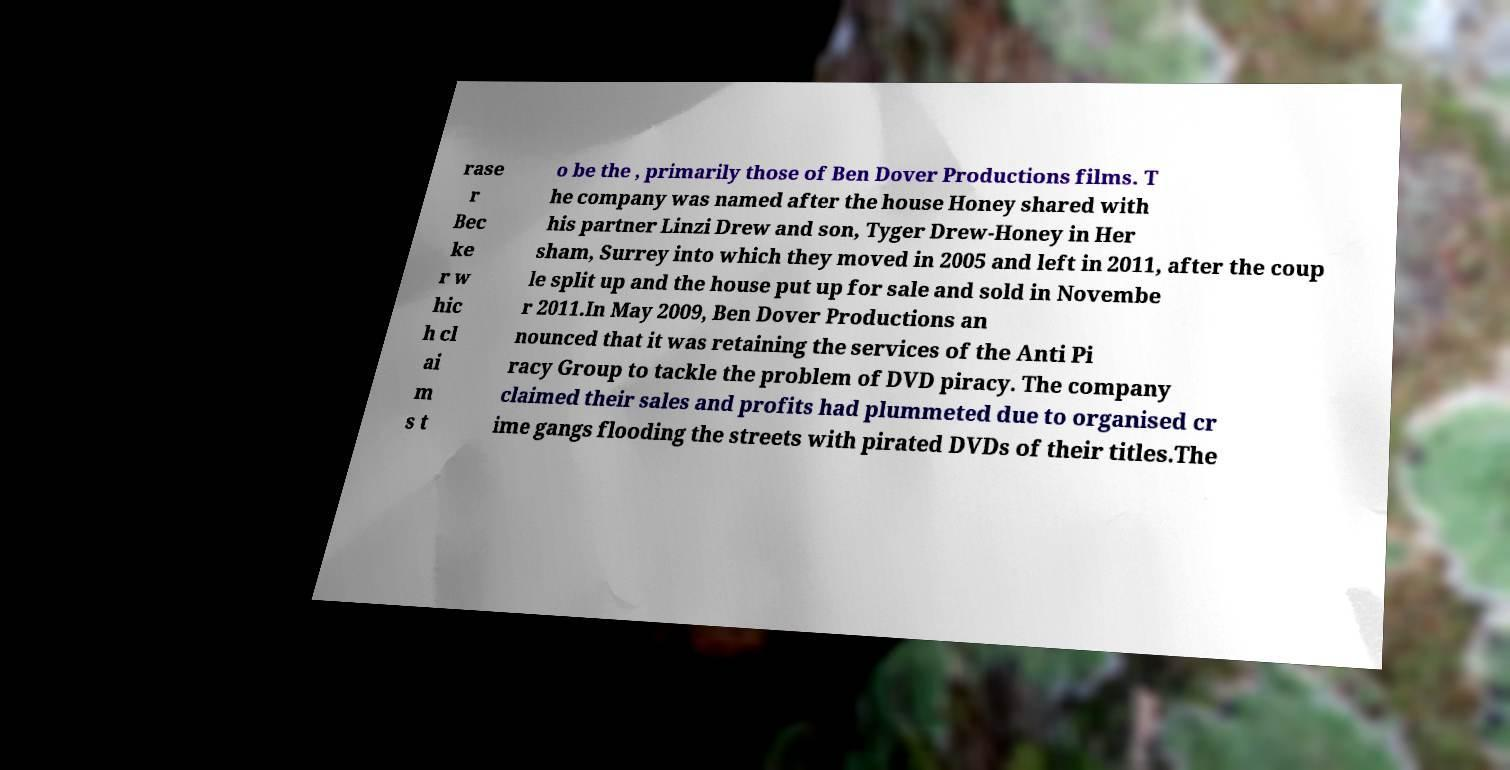There's text embedded in this image that I need extracted. Can you transcribe it verbatim? rase r Bec ke r w hic h cl ai m s t o be the , primarily those of Ben Dover Productions films. T he company was named after the house Honey shared with his partner Linzi Drew and son, Tyger Drew-Honey in Her sham, Surrey into which they moved in 2005 and left in 2011, after the coup le split up and the house put up for sale and sold in Novembe r 2011.In May 2009, Ben Dover Productions an nounced that it was retaining the services of the Anti Pi racy Group to tackle the problem of DVD piracy. The company claimed their sales and profits had plummeted due to organised cr ime gangs flooding the streets with pirated DVDs of their titles.The 